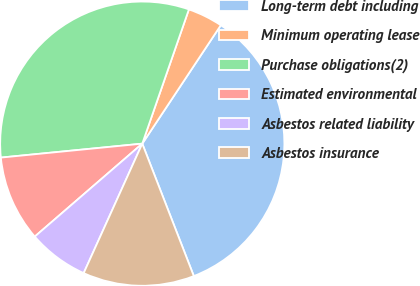Convert chart. <chart><loc_0><loc_0><loc_500><loc_500><pie_chart><fcel>Long-term debt including<fcel>Minimum operating lease<fcel>Purchase obligations(2)<fcel>Estimated environmental<fcel>Asbestos related liability<fcel>Asbestos insurance<nl><fcel>34.77%<fcel>4.0%<fcel>31.88%<fcel>9.78%<fcel>6.89%<fcel>12.67%<nl></chart> 